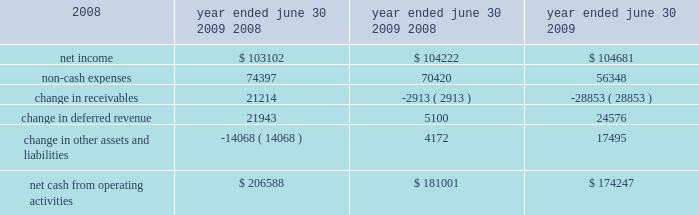26 | 2009 annual report in fiscal 2008 , revenues in the credit union systems and services business segment increased 14% ( 14 % ) from fiscal 2007 .
All revenue components within the segment experienced growth during fiscal 2008 .
License revenue generated the largest dollar growth in revenue as episys ae , our flagship core processing system aimed at larger credit unions , experienced strong sales throughout the year .
Support and service revenue , which is the largest component of total revenues for the credit union segment , experienced 34 percent growth in eft support and 10 percent growth in in-house support .
Gross profit in this business segment increased $ 9344 in fiscal 2008 compared to fiscal 2007 , due primarily to the increase in license revenue , which carries the highest margins .
Liquidity and capital resources we have historically generated positive cash flow from operations and have generally used funds generated from operations and short-term borrowings on our revolving credit facility to meet capital requirements .
We expect this trend to continue in the future .
The company 2019s cash and cash equivalents increased to $ 118251 at june 30 , 2009 from $ 65565 at june 30 , 2008 .
The table summarizes net cash from operating activities in the statement of cash flows : 2009 2008 2007 .
Year ended june 30 , cash provided by operations increased $ 25587 to $ 206588 for the fiscal year ended june 30 , 2009 as compared to $ 181001 for the fiscal year ended june 30 , 2008 .
This increase is primarily attributable to a decrease in receivables compared to the same period a year ago of $ 21214 .
This decrease is largely the result of fiscal 2010 annual software maintenance billings being provided to customers earlier than in the prior year , which allowed more cash to be collected before the end of the fiscal year than in previous years .
Further , we collected more cash overall related to revenues that will be recognized in subsequent periods in the current year than in fiscal 2008 .
Cash used in investing activities for the fiscal year ended june 2009 was $ 59227 and includes $ 3027 in contingent consideration paid on prior years 2019 acquisitions .
Cash used in investing activities for the fiscal year ended june 2008 was $ 102148 and includes payments for acquisitions of $ 48109 , plus $ 1215 in contingent consideration paid on prior years 2019 acquisitions .
Capital expenditures for fiscal 2009 were $ 31562 compared to $ 31105 for fiscal 2008 .
Cash used for software development in fiscal 2009 was $ 24684 compared to $ 23736 during the prior year .
Net cash used in financing activities for the current fiscal year was $ 94675 and includes the repurchase of 3106 shares of our common stock for $ 58405 , the payment of dividends of $ 26903 and $ 13489 net repayment on our revolving credit facilities .
Cash used in financing activities was partially offset by proceeds of $ 3773 from the exercise of stock options and the sale of common stock ( through the employee stock purchase plan ) and $ 348 excess tax benefits from stock option exercises .
During fiscal 2008 , net cash used in financing activities for the fiscal year was $ 101905 and includes the repurchase of 4200 shares of our common stock for $ 100996 , the payment of dividends of $ 24683 and $ 429 net repayment on our revolving credit facilities .
Cash used in financing activities was partially offset by proceeds of $ 20394 from the exercise of stock options and the sale of common stock and $ 3809 excess tax benefits from stock option exercises .
Beginning during fiscal 2008 , us financial markets and many of the largest us financial institutions have been shaken by negative developments in the home mortgage industry and the mortgage markets , and particularly the markets for subprime mortgage-backed securities .
Since that time , these and other such developments have resulted in a broad , global economic downturn .
While we , as is the case with most companies , have experienced the effects of this downturn , we have not experienced any significant issues with our current collection efforts , and we believe that any future impact to our liquidity will be minimized by cash generated by recurring sources of revenue and due to our access to available lines of credit. .
What was the percentage change in the company 2019s cash and cash equivalents from june 302008 to 2009? 
Computations: ((118251 - 65565) / 65565)
Answer: 0.80357. 